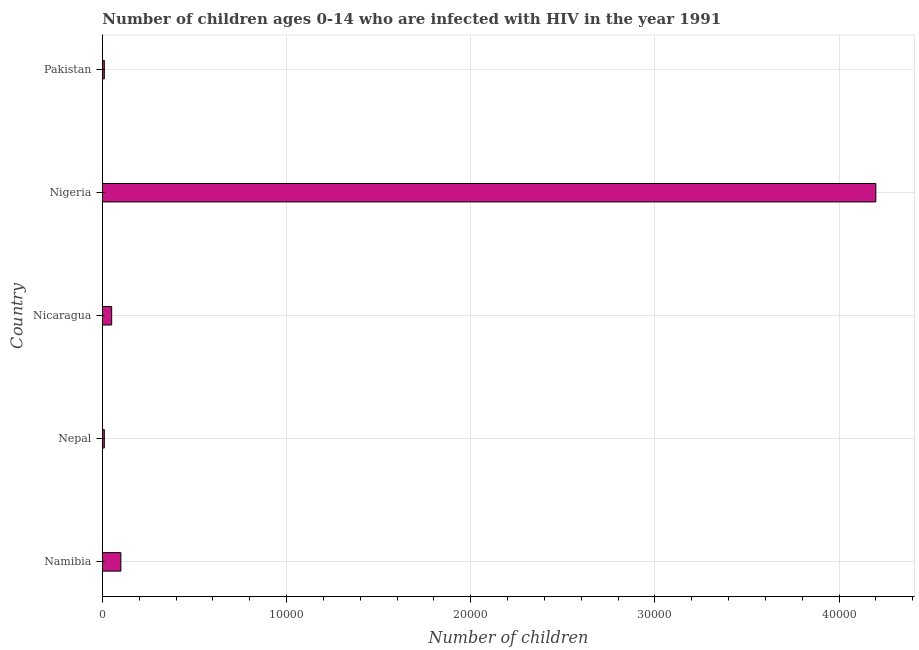What is the title of the graph?
Ensure brevity in your answer.  Number of children ages 0-14 who are infected with HIV in the year 1991. What is the label or title of the X-axis?
Your answer should be compact. Number of children. What is the label or title of the Y-axis?
Offer a very short reply. Country. What is the number of children living with hiv in Nigeria?
Make the answer very short. 4.20e+04. Across all countries, what is the maximum number of children living with hiv?
Provide a short and direct response. 4.20e+04. In which country was the number of children living with hiv maximum?
Keep it short and to the point. Nigeria. In which country was the number of children living with hiv minimum?
Give a very brief answer. Nepal. What is the sum of the number of children living with hiv?
Ensure brevity in your answer.  4.37e+04. What is the average number of children living with hiv per country?
Give a very brief answer. 8740. What is the median number of children living with hiv?
Provide a succinct answer. 500. What is the ratio of the number of children living with hiv in Nepal to that in Nigeria?
Give a very brief answer. 0. What is the difference between the highest and the second highest number of children living with hiv?
Offer a terse response. 4.10e+04. What is the difference between the highest and the lowest number of children living with hiv?
Make the answer very short. 4.19e+04. In how many countries, is the number of children living with hiv greater than the average number of children living with hiv taken over all countries?
Your response must be concise. 1. Are all the bars in the graph horizontal?
Make the answer very short. Yes. How many countries are there in the graph?
Offer a very short reply. 5. Are the values on the major ticks of X-axis written in scientific E-notation?
Your answer should be very brief. No. What is the Number of children in Namibia?
Your answer should be very brief. 1000. What is the Number of children in Nepal?
Your response must be concise. 100. What is the Number of children in Nigeria?
Keep it short and to the point. 4.20e+04. What is the Number of children in Pakistan?
Your answer should be very brief. 100. What is the difference between the Number of children in Namibia and Nepal?
Make the answer very short. 900. What is the difference between the Number of children in Namibia and Nigeria?
Your response must be concise. -4.10e+04. What is the difference between the Number of children in Namibia and Pakistan?
Provide a succinct answer. 900. What is the difference between the Number of children in Nepal and Nicaragua?
Your answer should be compact. -400. What is the difference between the Number of children in Nepal and Nigeria?
Your response must be concise. -4.19e+04. What is the difference between the Number of children in Nepal and Pakistan?
Offer a terse response. 0. What is the difference between the Number of children in Nicaragua and Nigeria?
Offer a terse response. -4.15e+04. What is the difference between the Number of children in Nicaragua and Pakistan?
Provide a succinct answer. 400. What is the difference between the Number of children in Nigeria and Pakistan?
Your answer should be compact. 4.19e+04. What is the ratio of the Number of children in Namibia to that in Nicaragua?
Your response must be concise. 2. What is the ratio of the Number of children in Namibia to that in Nigeria?
Your response must be concise. 0.02. What is the ratio of the Number of children in Namibia to that in Pakistan?
Provide a succinct answer. 10. What is the ratio of the Number of children in Nepal to that in Nicaragua?
Your answer should be very brief. 0.2. What is the ratio of the Number of children in Nepal to that in Nigeria?
Provide a short and direct response. 0. What is the ratio of the Number of children in Nicaragua to that in Nigeria?
Keep it short and to the point. 0.01. What is the ratio of the Number of children in Nigeria to that in Pakistan?
Make the answer very short. 420. 